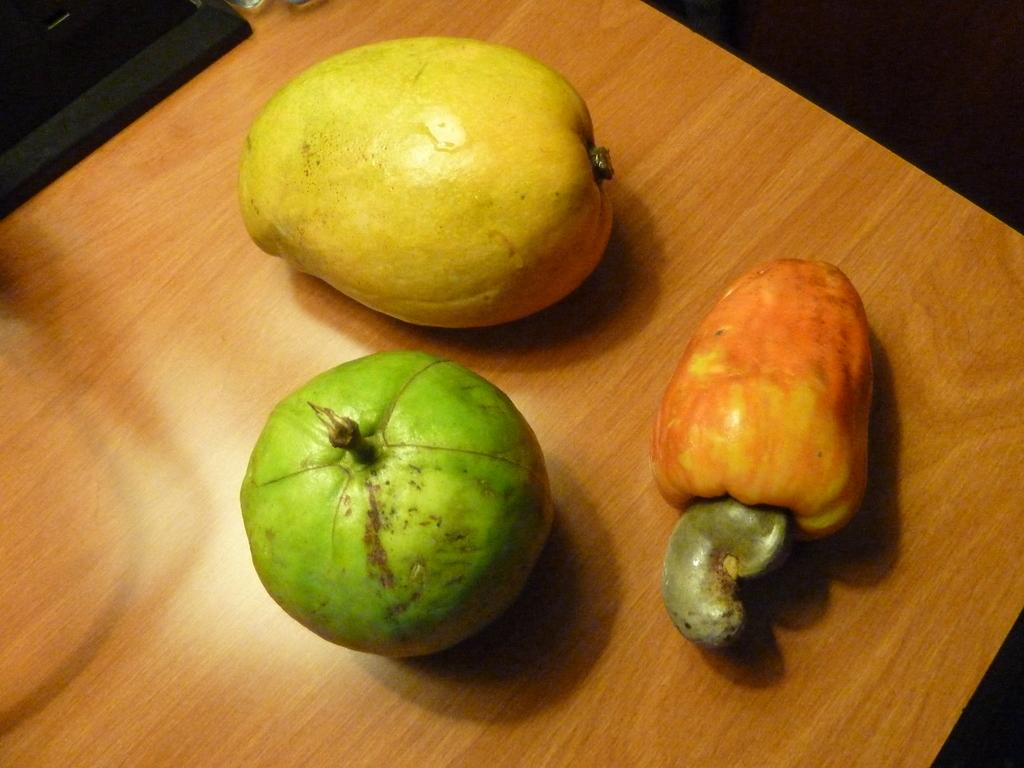How many fruits are visible in the image? There are three fruits in the image. What is the surface on which the fruits are placed? The fruits are placed on a wooden surface. What type of house is depicted in the image? There is no house present in the image; it only features three fruits on a wooden surface. What songs can be heard playing in the background of the image? There is no audio or background music present in the image; it only features three fruits on a wooden surface. 